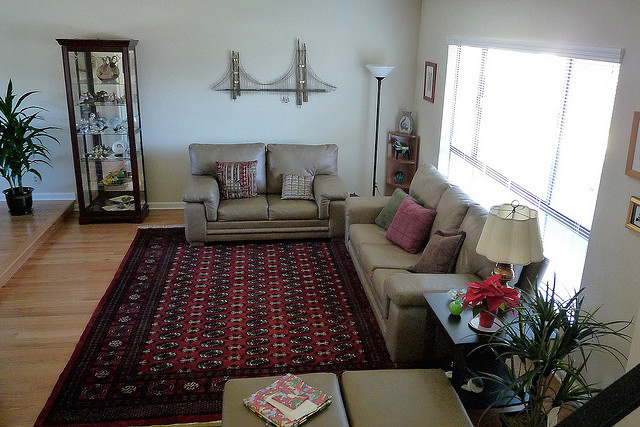<image>What kind of flowers are in the vase? It is ambiguous what kind of flowers are in the vase, as it could be roses, tulips, poinsettia, or lily. What holiday is this? I am not sure what holiday this is. It is perceived as Christmas or Thanksgiving. What holiday is this? This holiday is Christmas. What kind of flowers are in the vase? I am not sure what kind of flowers are in the vase. It can be seen roses, tulips, poinsettia or red flowers. 